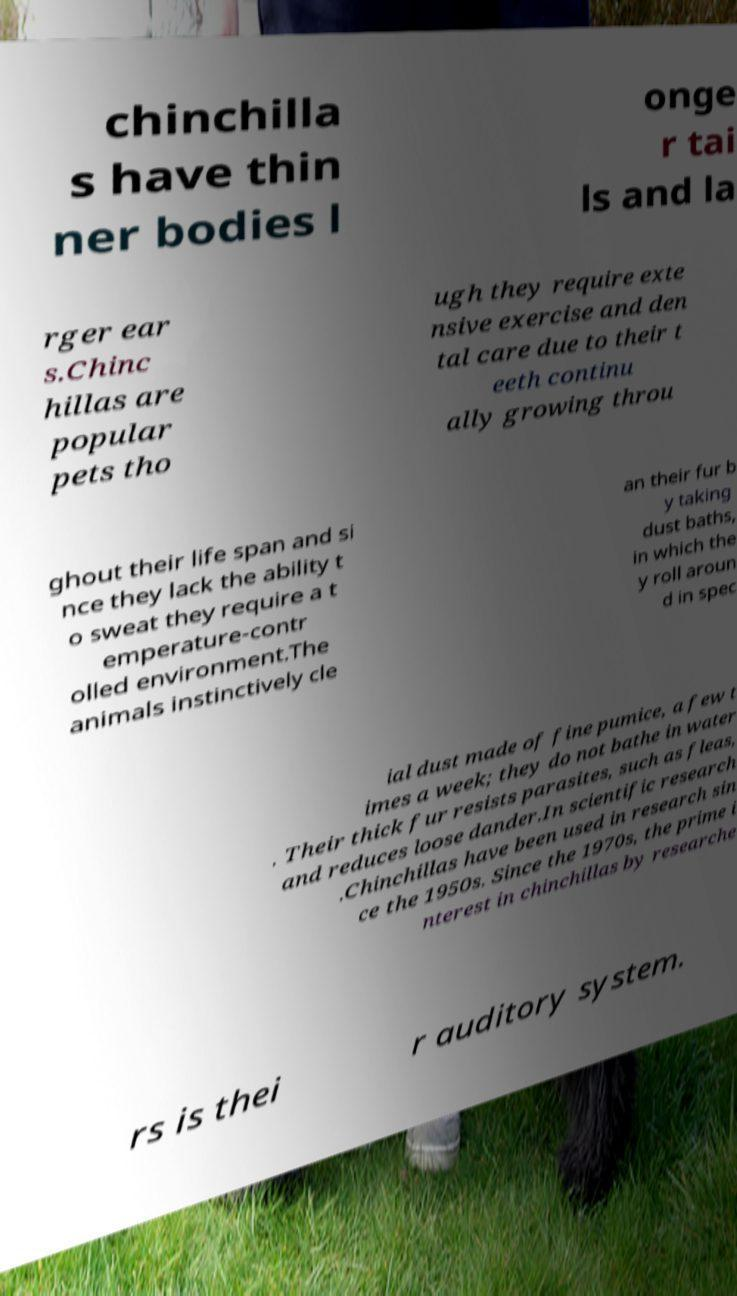What messages or text are displayed in this image? I need them in a readable, typed format. chinchilla s have thin ner bodies l onge r tai ls and la rger ear s.Chinc hillas are popular pets tho ugh they require exte nsive exercise and den tal care due to their t eeth continu ally growing throu ghout their life span and si nce they lack the ability t o sweat they require a t emperature-contr olled environment.The animals instinctively cle an their fur b y taking dust baths, in which the y roll aroun d in spec ial dust made of fine pumice, a few t imes a week; they do not bathe in water . Their thick fur resists parasites, such as fleas, and reduces loose dander.In scientific research .Chinchillas have been used in research sin ce the 1950s. Since the 1970s, the prime i nterest in chinchillas by researche rs is thei r auditory system. 